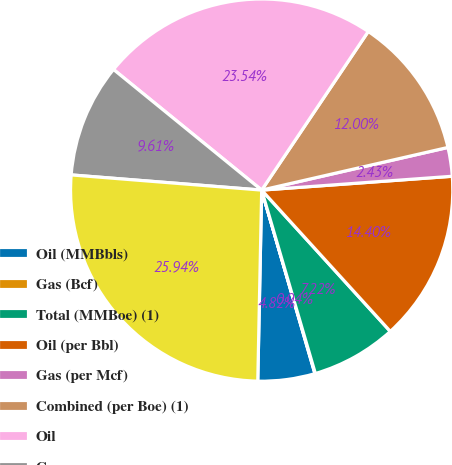Convert chart to OTSL. <chart><loc_0><loc_0><loc_500><loc_500><pie_chart><fcel>Oil (MMBbls)<fcel>Gas (Bcf)<fcel>Total (MMBoe) (1)<fcel>Oil (per Bbl)<fcel>Gas (per Mcf)<fcel>Combined (per Boe) (1)<fcel>Oil<fcel>Gas<fcel>Total<nl><fcel>4.82%<fcel>0.04%<fcel>7.22%<fcel>14.4%<fcel>2.43%<fcel>12.0%<fcel>23.54%<fcel>9.61%<fcel>25.94%<nl></chart> 